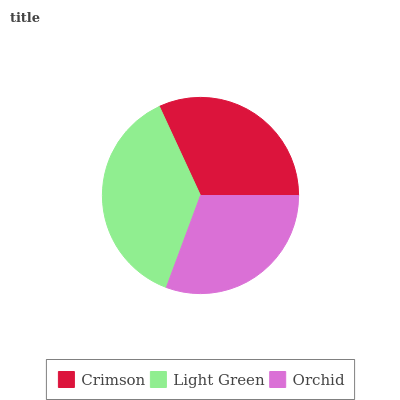Is Orchid the minimum?
Answer yes or no. Yes. Is Light Green the maximum?
Answer yes or no. Yes. Is Light Green the minimum?
Answer yes or no. No. Is Orchid the maximum?
Answer yes or no. No. Is Light Green greater than Orchid?
Answer yes or no. Yes. Is Orchid less than Light Green?
Answer yes or no. Yes. Is Orchid greater than Light Green?
Answer yes or no. No. Is Light Green less than Orchid?
Answer yes or no. No. Is Crimson the high median?
Answer yes or no. Yes. Is Crimson the low median?
Answer yes or no. Yes. Is Orchid the high median?
Answer yes or no. No. Is Orchid the low median?
Answer yes or no. No. 